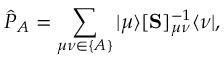<formula> <loc_0><loc_0><loc_500><loc_500>\hat { P } _ { A } = \sum _ { \mu \nu \in \{ A \} } | \mu \rangle [ S ] _ { \mu \nu } ^ { - 1 } \langle \nu | ,</formula> 